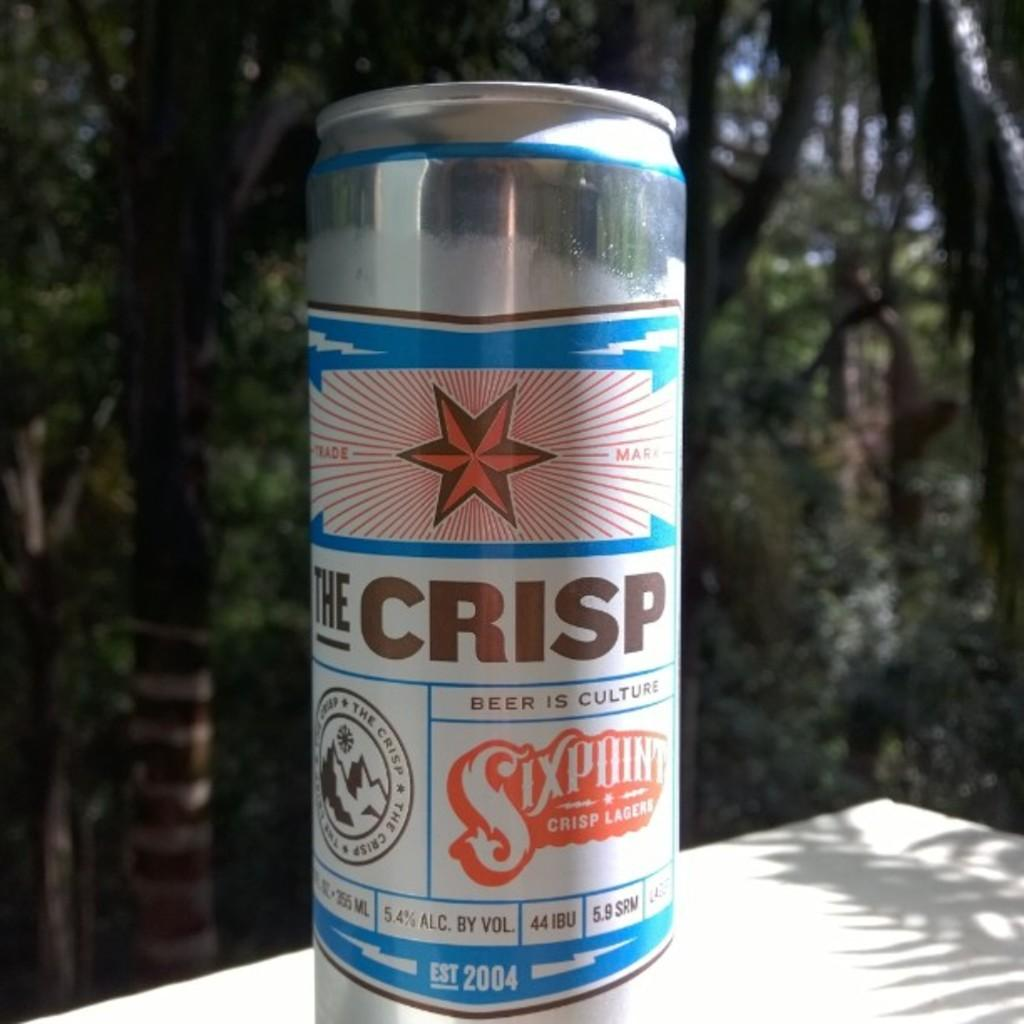<image>
Write a terse but informative summary of the picture. A can of The Crisp has a big red star on it. 